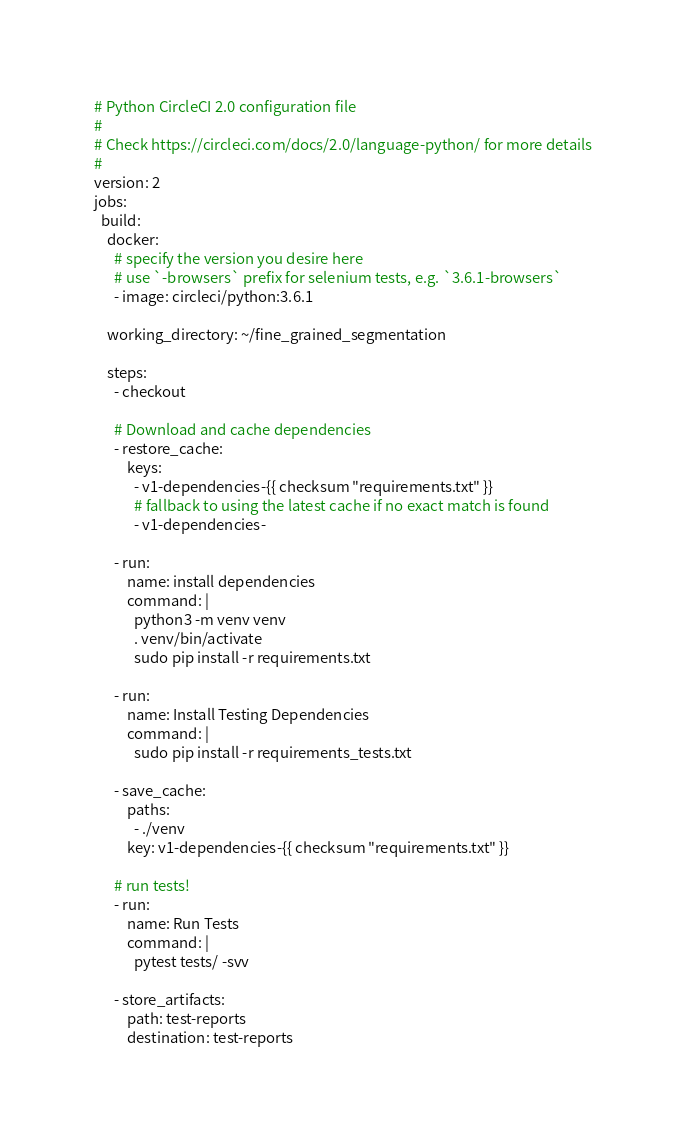<code> <loc_0><loc_0><loc_500><loc_500><_YAML_># Python CircleCI 2.0 configuration file
#
# Check https://circleci.com/docs/2.0/language-python/ for more details
#
version: 2
jobs:
  build:
    docker:
      # specify the version you desire here
      # use `-browsers` prefix for selenium tests, e.g. `3.6.1-browsers`
      - image: circleci/python:3.6.1

    working_directory: ~/fine_grained_segmentation

    steps:
      - checkout

      # Download and cache dependencies
      - restore_cache:
          keys:
            - v1-dependencies-{{ checksum "requirements.txt" }}
            # fallback to using the latest cache if no exact match is found
            - v1-dependencies-

      - run:
          name: install dependencies
          command: |
            python3 -m venv venv
            . venv/bin/activate
            sudo pip install -r requirements.txt
            
      - run:
          name: Install Testing Dependencies
          command: |
            sudo pip install -r requirements_tests.txt

      - save_cache:
          paths:
            - ./venv
          key: v1-dependencies-{{ checksum "requirements.txt" }}

      # run tests!
      - run:
          name: Run Tests
          command: |
            pytest tests/ -svv

      - store_artifacts:
          path: test-reports
          destination: test-reports</code> 